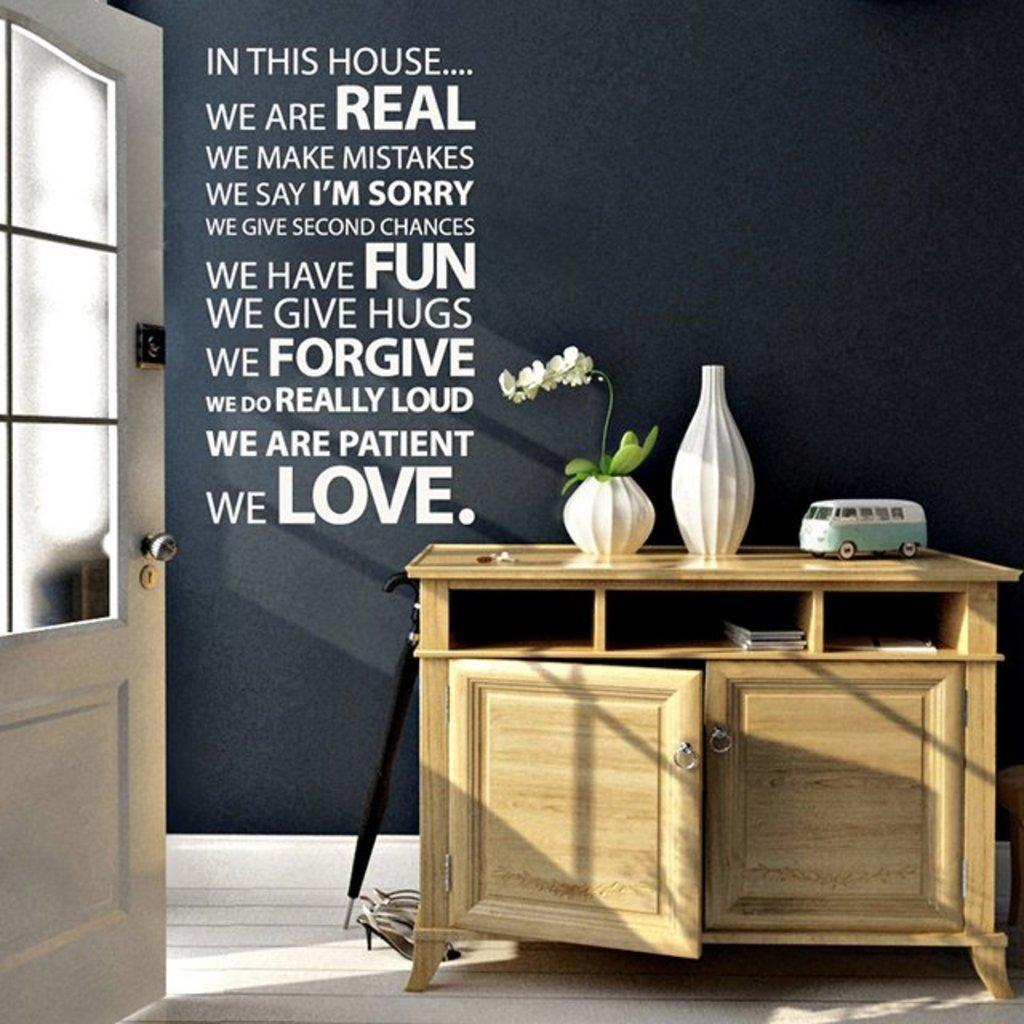What type of furniture is present in the image? There is a table in the image. What feature does the table have? The table has cabinets. What items can be seen on the table? There are books and a flower pot on the table. What is written on the wall in the image? There is text written on the wall. What type of door is visible in the image? There is a white door in the image. How many balloons are floating above the table in the image? There are no balloons present in the image. What type of vegetable is growing in the flower pot on the table? There is no vegetable growing in the flower pot on the table; it contains a plant or flowers. 